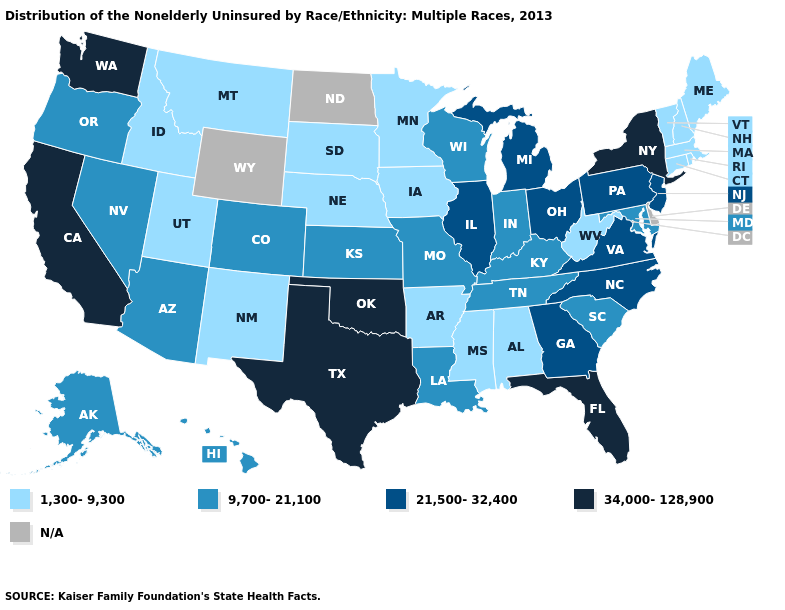What is the value of Maryland?
Concise answer only. 9,700-21,100. Does Iowa have the lowest value in the USA?
Be succinct. Yes. Name the states that have a value in the range 21,500-32,400?
Be succinct. Georgia, Illinois, Michigan, New Jersey, North Carolina, Ohio, Pennsylvania, Virginia. What is the value of Montana?
Concise answer only. 1,300-9,300. What is the value of Maryland?
Short answer required. 9,700-21,100. What is the lowest value in the USA?
Concise answer only. 1,300-9,300. What is the highest value in states that border Ohio?
Keep it brief. 21,500-32,400. What is the lowest value in the USA?
Be succinct. 1,300-9,300. Name the states that have a value in the range 21,500-32,400?
Answer briefly. Georgia, Illinois, Michigan, New Jersey, North Carolina, Ohio, Pennsylvania, Virginia. Name the states that have a value in the range N/A?
Write a very short answer. Delaware, North Dakota, Wyoming. Among the states that border North Carolina , does Tennessee have the lowest value?
Short answer required. Yes. Name the states that have a value in the range 9,700-21,100?
Quick response, please. Alaska, Arizona, Colorado, Hawaii, Indiana, Kansas, Kentucky, Louisiana, Maryland, Missouri, Nevada, Oregon, South Carolina, Tennessee, Wisconsin. Which states have the highest value in the USA?
Keep it brief. California, Florida, New York, Oklahoma, Texas, Washington. How many symbols are there in the legend?
Short answer required. 5. 